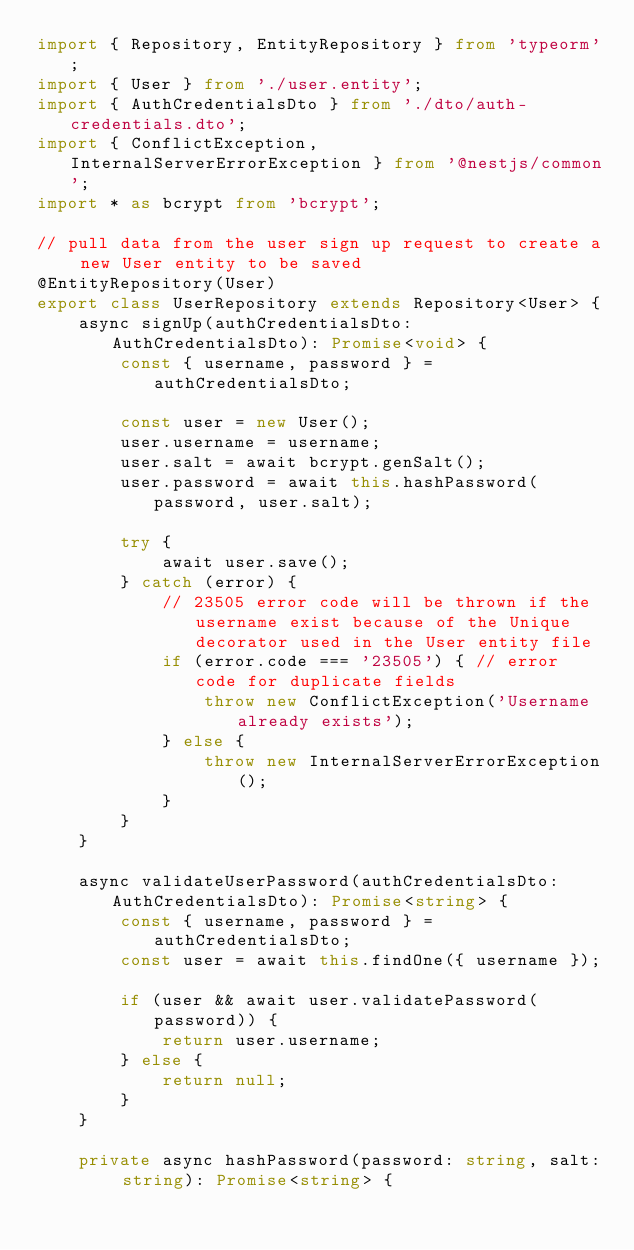<code> <loc_0><loc_0><loc_500><loc_500><_TypeScript_>import { Repository, EntityRepository } from 'typeorm';
import { User } from './user.entity';
import { AuthCredentialsDto } from './dto/auth-credentials.dto';
import { ConflictException, InternalServerErrorException } from '@nestjs/common';
import * as bcrypt from 'bcrypt';

// pull data from the user sign up request to create a new User entity to be saved
@EntityRepository(User)
export class UserRepository extends Repository<User> {
    async signUp(authCredentialsDto: AuthCredentialsDto): Promise<void> {
        const { username, password } = authCredentialsDto;

        const user = new User();
        user.username = username;
        user.salt = await bcrypt.genSalt();
        user.password = await this.hashPassword(password, user.salt);

        try {
            await user.save();
        } catch (error) {
            // 23505 error code will be thrown if the username exist because of the Unique decorator used in the User entity file
            if (error.code === '23505') { // error code for duplicate fields
                throw new ConflictException('Username already exists');
            } else {
                throw new InternalServerErrorException();
            }
        }
    }

    async validateUserPassword(authCredentialsDto: AuthCredentialsDto): Promise<string> {
        const { username, password } = authCredentialsDto;
        const user = await this.findOne({ username });

        if (user && await user.validatePassword(password)) {
            return user.username;
        } else {
            return null;
        }
    }

    private async hashPassword(password: string, salt: string): Promise<string> {</code> 